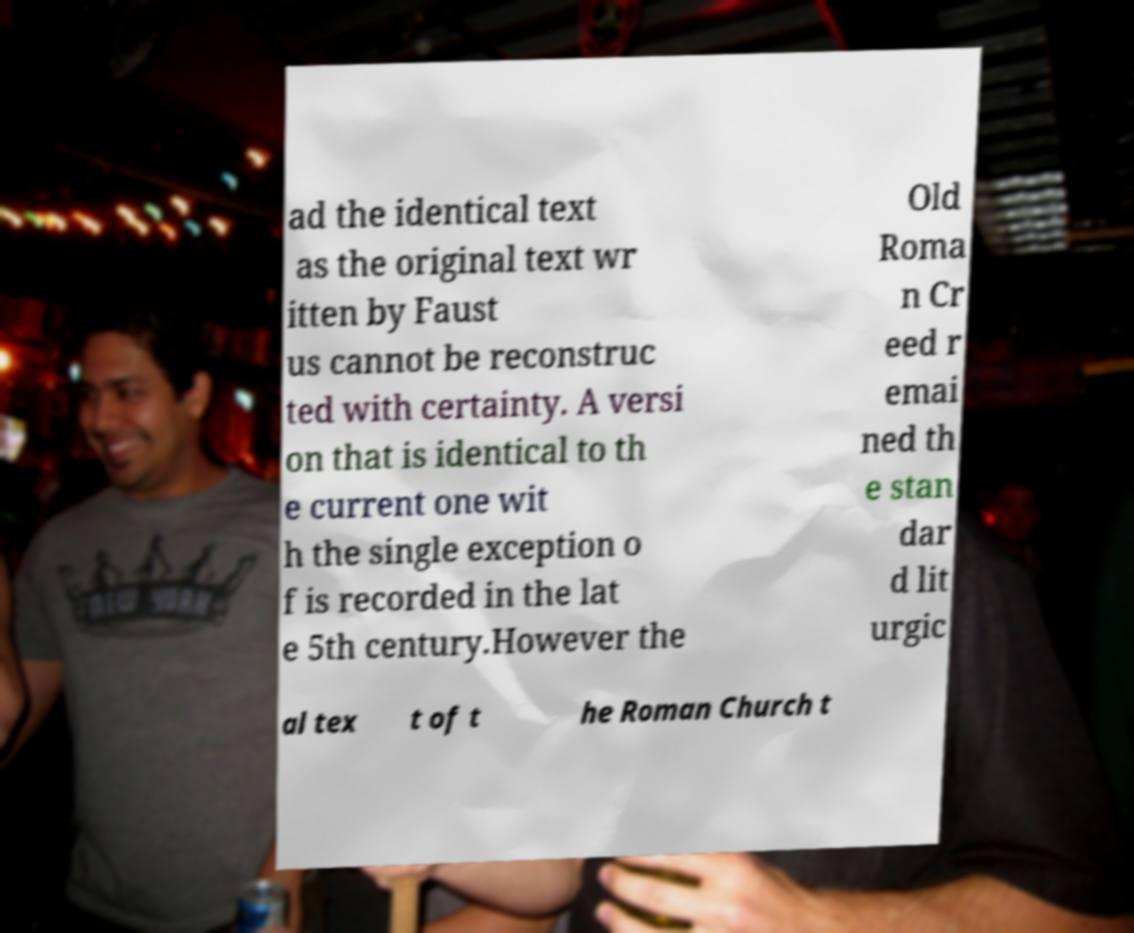Can you read and provide the text displayed in the image?This photo seems to have some interesting text. Can you extract and type it out for me? ad the identical text as the original text wr itten by Faust us cannot be reconstruc ted with certainty. A versi on that is identical to th e current one wit h the single exception o f is recorded in the lat e 5th century.However the Old Roma n Cr eed r emai ned th e stan dar d lit urgic al tex t of t he Roman Church t 